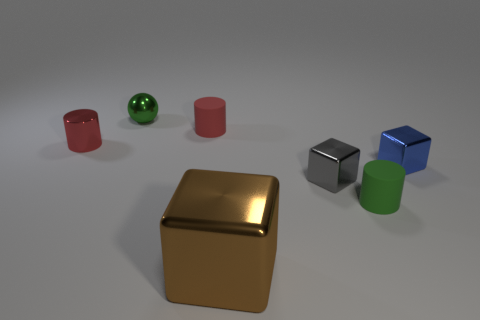Can you describe the possible materials of the objects in the image? Certainly! The golden cube in front has a smooth, reflective surface that suggests it could be made of polished brass or gold. The blue and gray cubes have slightly less reflective surfaces, possibly indicating a matte metal or plastic finish. The green sphere and the red cylinder could be made of polished plastic or glass due to their lustrous appearance, while the pink cylinder has a matte finish that might be a painted metal or clay. 